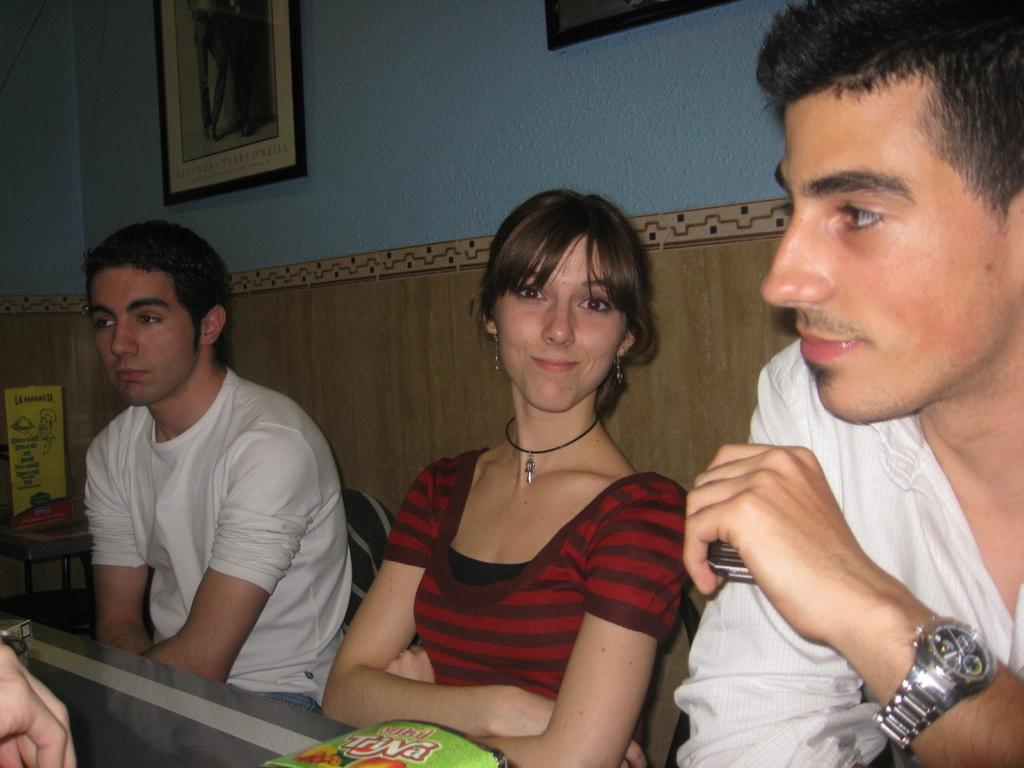What are the people in the image doing? The people in the image are sitting. What can be seen on the table in the image? There are objects on a table in the image. What is visible on the wall in the background of the image? There are frames on the wall in the background of the image. What is placed on a stand in the background of the image? There is a box placed on a stand in the background of the image. What type of protest is happening in the image? There is no protest present in the image; it only shows people sitting and objects on a table, frames on the wall, and a box on a stand. 